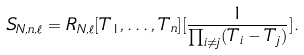<formula> <loc_0><loc_0><loc_500><loc_500>S _ { N , n , \ell } = R _ { N , \ell } [ T _ { 1 } , \dots , T _ { n } ] [ \frac { 1 } { \prod _ { i \neq j } ( T _ { i } - T _ { j } ) } ] .</formula> 